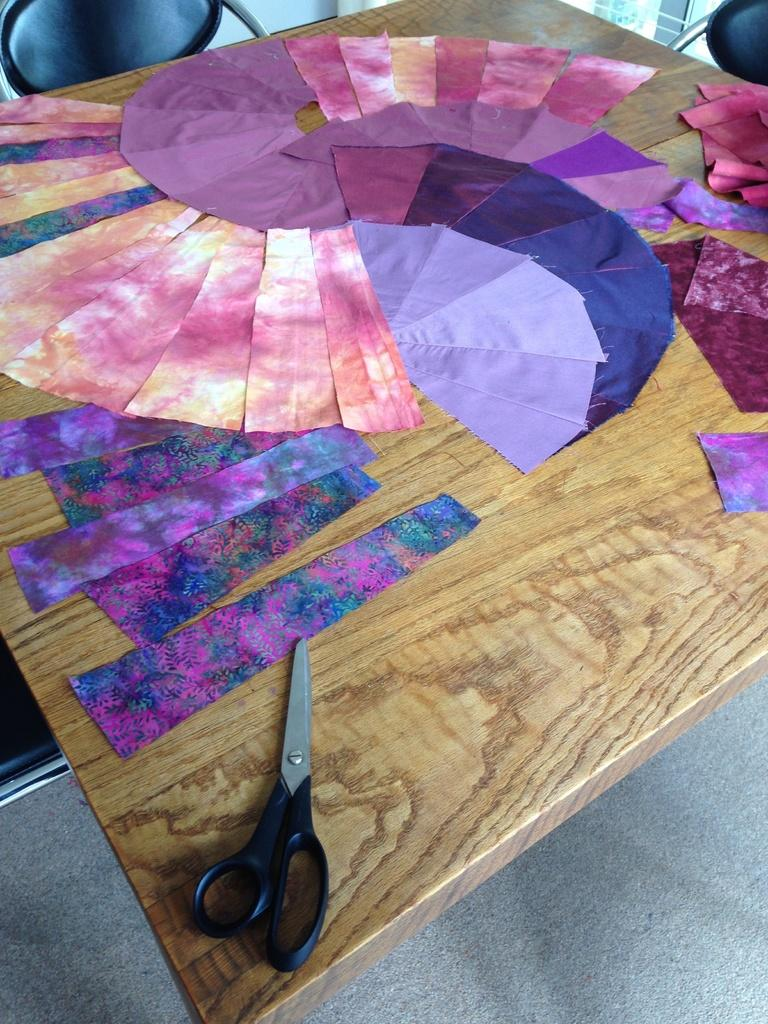What is on the table in the image? There is a colored cloth and a scissor on the table. What is the state of the cloth on the table? The cloth is cut into small pieces. Is there any furniture visible in the image? Yes, there is a chair in the image. What type of advice is being given by the plough in the image? There is no plough present in the image, so it is not possible to answer that question. 